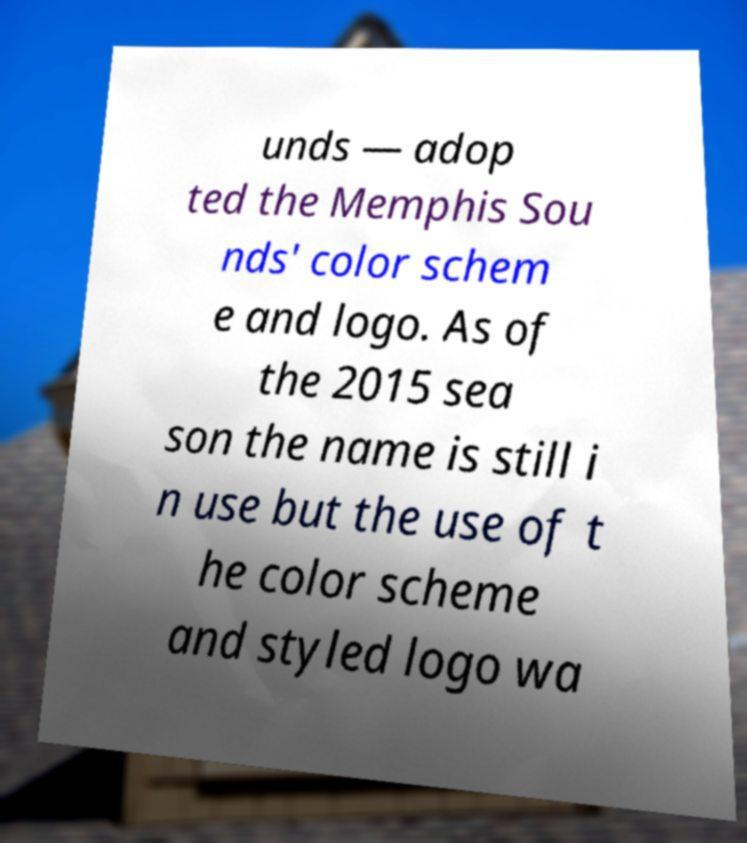Could you assist in decoding the text presented in this image and type it out clearly? unds — adop ted the Memphis Sou nds' color schem e and logo. As of the 2015 sea son the name is still i n use but the use of t he color scheme and styled logo wa 